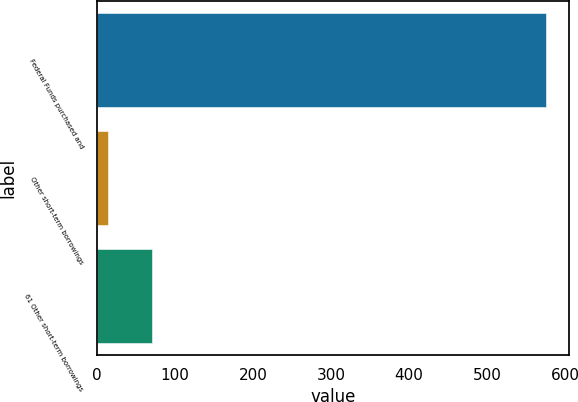Convert chart to OTSL. <chart><loc_0><loc_0><loc_500><loc_500><bar_chart><fcel>Federal Funds purchased and<fcel>Other short-term borrowings<fcel>61 Other short-term borrowings<nl><fcel>576<fcel>14<fcel>70.2<nl></chart> 